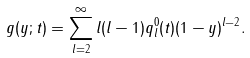<formula> <loc_0><loc_0><loc_500><loc_500>g ( y ; t ) = \sum _ { l = 2 } ^ { \infty } l ( l - 1 ) q _ { l } ^ { 0 } ( t ) ( 1 - y ) ^ { l - 2 } .</formula> 